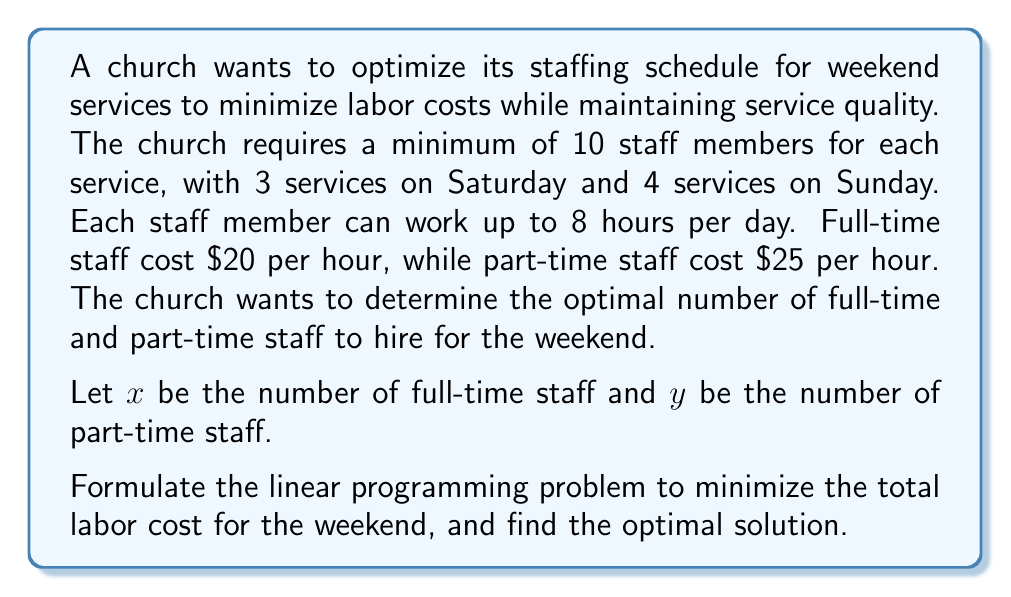Give your solution to this math problem. To solve this problem, we need to set up a linear programming model and then solve it.

1. Define the objective function:
   We want to minimize the total labor cost for the weekend.
   Cost = (16 hours * $20/hour * x) + (16 hours * $25/hour * y)
   Objective function: Minimize $Z = 320x + 400y$

2. Define the constraints:
   a) Minimum staff requirement for all services:
      $(3 + 4) * 10 = 70$ staff-services needed
      Each full-time staff can cover 7 services (56 hours / 8 hours)
      Each part-time staff can cover 2 services (16 hours / 8 hours)
      Constraint: $7x + 2y \geq 70$

   b) Non-negativity constraints:
      $x \geq 0$, $y \geq 0$

3. Solve the linear programming problem:
   We can solve this using the graphical method or the simplex method. Let's use the graphical method.

   a) Plot the constraint: $7x + 2y = 70$
   b) The feasible region is above this line and in the first quadrant.
   c) Plot the objective function lines: $320x + 400y = k$ for different values of k.
   d) The optimal solution will be at the vertex of the feasible region that gives the lowest value of k.

4. Find the optimal solution:
   The vertex of interest is where the constraint line intersects the y-axis.
   At this point, $x = 0$ and $y = 35$

5. Verify the solution:
   $7(0) + 2(35) = 70$, which satisfies the constraint.
   The total cost is: $320(0) + 400(35) = 14,000$

Therefore, the optimal solution is to hire 35 part-time staff members for the weekend.
Answer: The optimal solution is to hire 0 full-time staff and 35 part-time staff, resulting in a total labor cost of $14,000 for the weekend. 